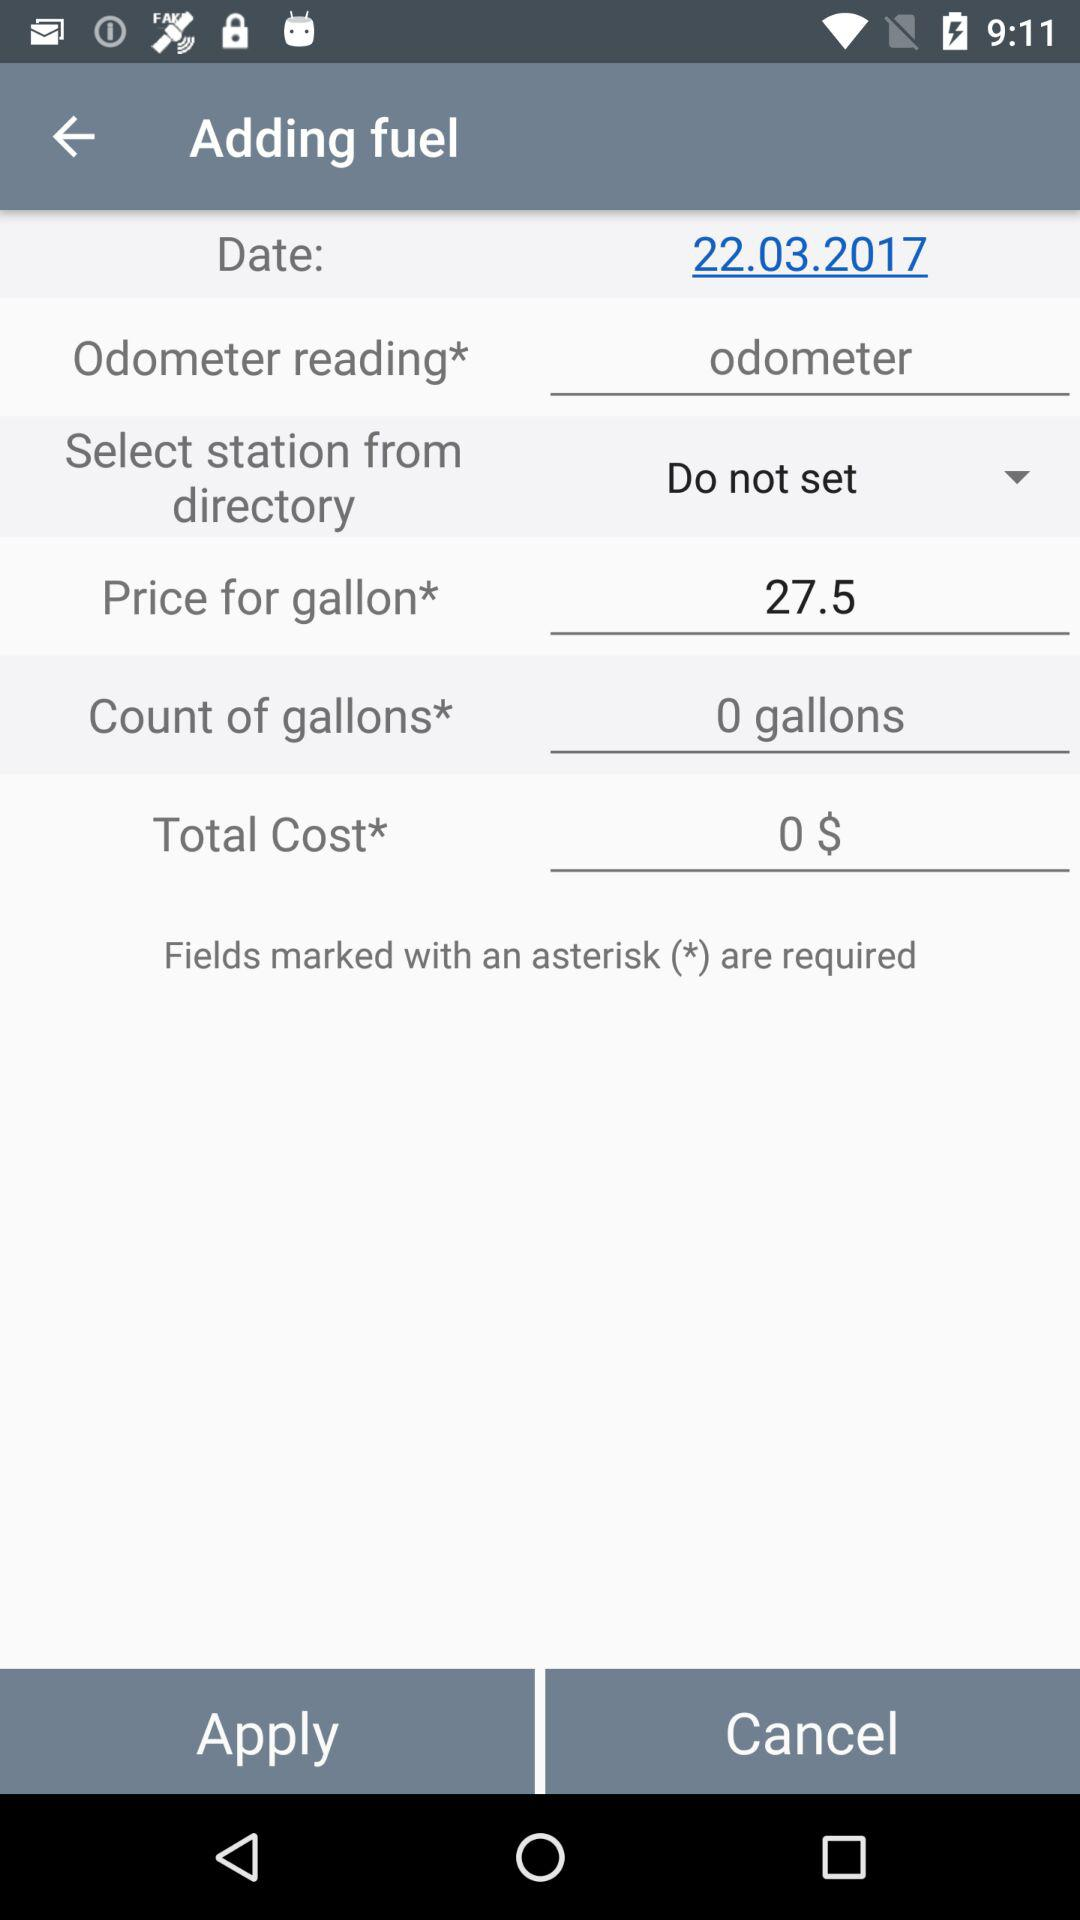What is the currency for the total cost of fuel? The currency for the total cost of fuel is dollars. 